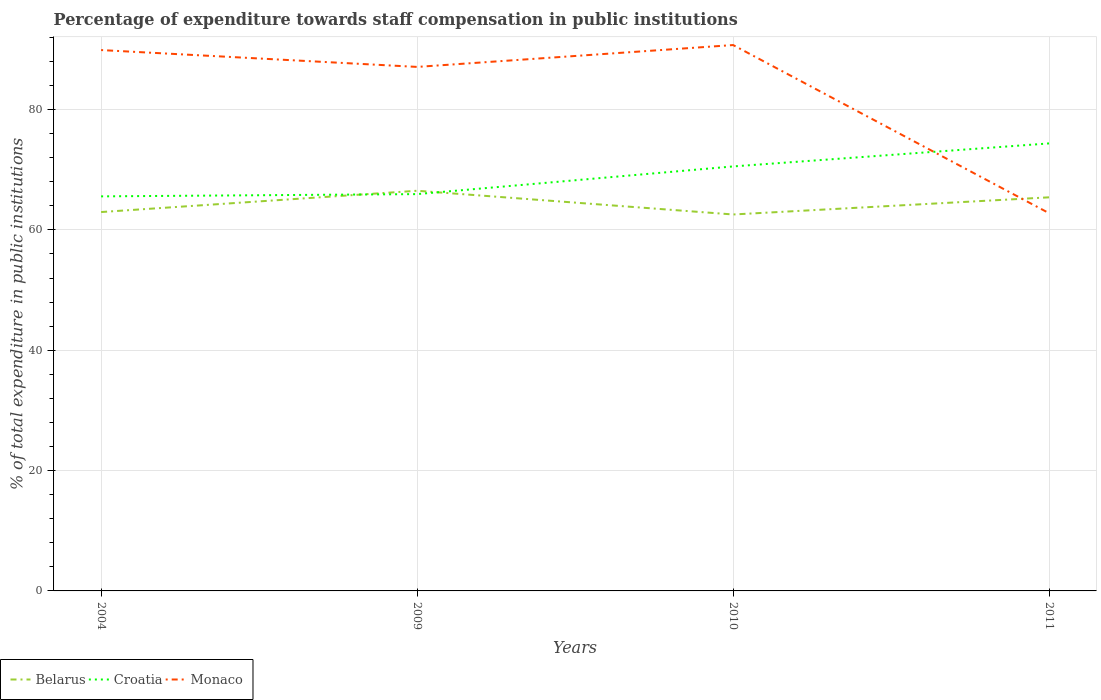Does the line corresponding to Monaco intersect with the line corresponding to Belarus?
Your answer should be compact. Yes. Across all years, what is the maximum percentage of expenditure towards staff compensation in Belarus?
Offer a very short reply. 62.57. What is the total percentage of expenditure towards staff compensation in Belarus in the graph?
Keep it short and to the point. -3.54. What is the difference between the highest and the second highest percentage of expenditure towards staff compensation in Belarus?
Provide a short and direct response. 3.94. What is the difference between the highest and the lowest percentage of expenditure towards staff compensation in Monaco?
Provide a short and direct response. 3. Is the percentage of expenditure towards staff compensation in Belarus strictly greater than the percentage of expenditure towards staff compensation in Monaco over the years?
Give a very brief answer. No. How many years are there in the graph?
Offer a terse response. 4. What is the difference between two consecutive major ticks on the Y-axis?
Offer a very short reply. 20. Are the values on the major ticks of Y-axis written in scientific E-notation?
Keep it short and to the point. No. Does the graph contain any zero values?
Keep it short and to the point. No. Where does the legend appear in the graph?
Provide a succinct answer. Bottom left. How many legend labels are there?
Keep it short and to the point. 3. What is the title of the graph?
Provide a succinct answer. Percentage of expenditure towards staff compensation in public institutions. Does "Andorra" appear as one of the legend labels in the graph?
Keep it short and to the point. No. What is the label or title of the X-axis?
Provide a succinct answer. Years. What is the label or title of the Y-axis?
Provide a succinct answer. % of total expenditure in public institutions. What is the % of total expenditure in public institutions in Belarus in 2004?
Make the answer very short. 62.97. What is the % of total expenditure in public institutions in Croatia in 2004?
Provide a short and direct response. 65.58. What is the % of total expenditure in public institutions in Monaco in 2004?
Your answer should be compact. 89.9. What is the % of total expenditure in public institutions of Belarus in 2009?
Ensure brevity in your answer.  66.51. What is the % of total expenditure in public institutions in Croatia in 2009?
Your answer should be very brief. 65.95. What is the % of total expenditure in public institutions in Monaco in 2009?
Your answer should be compact. 87.1. What is the % of total expenditure in public institutions of Belarus in 2010?
Your answer should be compact. 62.57. What is the % of total expenditure in public institutions in Croatia in 2010?
Offer a very short reply. 70.56. What is the % of total expenditure in public institutions of Monaco in 2010?
Keep it short and to the point. 90.73. What is the % of total expenditure in public institutions in Belarus in 2011?
Give a very brief answer. 65.42. What is the % of total expenditure in public institutions in Croatia in 2011?
Your answer should be very brief. 74.38. What is the % of total expenditure in public institutions of Monaco in 2011?
Your response must be concise. 62.78. Across all years, what is the maximum % of total expenditure in public institutions in Belarus?
Make the answer very short. 66.51. Across all years, what is the maximum % of total expenditure in public institutions in Croatia?
Ensure brevity in your answer.  74.38. Across all years, what is the maximum % of total expenditure in public institutions in Monaco?
Your answer should be very brief. 90.73. Across all years, what is the minimum % of total expenditure in public institutions of Belarus?
Provide a succinct answer. 62.57. Across all years, what is the minimum % of total expenditure in public institutions in Croatia?
Your answer should be compact. 65.58. Across all years, what is the minimum % of total expenditure in public institutions of Monaco?
Give a very brief answer. 62.78. What is the total % of total expenditure in public institutions of Belarus in the graph?
Make the answer very short. 257.47. What is the total % of total expenditure in public institutions in Croatia in the graph?
Keep it short and to the point. 276.47. What is the total % of total expenditure in public institutions in Monaco in the graph?
Make the answer very short. 330.5. What is the difference between the % of total expenditure in public institutions of Belarus in 2004 and that in 2009?
Keep it short and to the point. -3.54. What is the difference between the % of total expenditure in public institutions of Croatia in 2004 and that in 2009?
Your response must be concise. -0.38. What is the difference between the % of total expenditure in public institutions in Monaco in 2004 and that in 2009?
Provide a short and direct response. 2.8. What is the difference between the % of total expenditure in public institutions in Belarus in 2004 and that in 2010?
Provide a short and direct response. 0.41. What is the difference between the % of total expenditure in public institutions in Croatia in 2004 and that in 2010?
Make the answer very short. -4.98. What is the difference between the % of total expenditure in public institutions in Monaco in 2004 and that in 2010?
Make the answer very short. -0.83. What is the difference between the % of total expenditure in public institutions of Belarus in 2004 and that in 2011?
Keep it short and to the point. -2.45. What is the difference between the % of total expenditure in public institutions of Croatia in 2004 and that in 2011?
Make the answer very short. -8.8. What is the difference between the % of total expenditure in public institutions of Monaco in 2004 and that in 2011?
Offer a very short reply. 27.11. What is the difference between the % of total expenditure in public institutions in Belarus in 2009 and that in 2010?
Provide a short and direct response. 3.94. What is the difference between the % of total expenditure in public institutions in Croatia in 2009 and that in 2010?
Make the answer very short. -4.6. What is the difference between the % of total expenditure in public institutions in Monaco in 2009 and that in 2010?
Your answer should be compact. -3.63. What is the difference between the % of total expenditure in public institutions of Belarus in 2009 and that in 2011?
Provide a succinct answer. 1.09. What is the difference between the % of total expenditure in public institutions in Croatia in 2009 and that in 2011?
Your answer should be compact. -8.43. What is the difference between the % of total expenditure in public institutions of Monaco in 2009 and that in 2011?
Give a very brief answer. 24.31. What is the difference between the % of total expenditure in public institutions of Belarus in 2010 and that in 2011?
Give a very brief answer. -2.85. What is the difference between the % of total expenditure in public institutions of Croatia in 2010 and that in 2011?
Your response must be concise. -3.82. What is the difference between the % of total expenditure in public institutions of Monaco in 2010 and that in 2011?
Offer a terse response. 27.95. What is the difference between the % of total expenditure in public institutions of Belarus in 2004 and the % of total expenditure in public institutions of Croatia in 2009?
Provide a short and direct response. -2.98. What is the difference between the % of total expenditure in public institutions of Belarus in 2004 and the % of total expenditure in public institutions of Monaco in 2009?
Your answer should be very brief. -24.12. What is the difference between the % of total expenditure in public institutions of Croatia in 2004 and the % of total expenditure in public institutions of Monaco in 2009?
Offer a terse response. -21.52. What is the difference between the % of total expenditure in public institutions of Belarus in 2004 and the % of total expenditure in public institutions of Croatia in 2010?
Provide a short and direct response. -7.58. What is the difference between the % of total expenditure in public institutions of Belarus in 2004 and the % of total expenditure in public institutions of Monaco in 2010?
Ensure brevity in your answer.  -27.76. What is the difference between the % of total expenditure in public institutions in Croatia in 2004 and the % of total expenditure in public institutions in Monaco in 2010?
Offer a very short reply. -25.15. What is the difference between the % of total expenditure in public institutions of Belarus in 2004 and the % of total expenditure in public institutions of Croatia in 2011?
Provide a succinct answer. -11.41. What is the difference between the % of total expenditure in public institutions in Belarus in 2004 and the % of total expenditure in public institutions in Monaco in 2011?
Make the answer very short. 0.19. What is the difference between the % of total expenditure in public institutions of Croatia in 2004 and the % of total expenditure in public institutions of Monaco in 2011?
Provide a short and direct response. 2.8. What is the difference between the % of total expenditure in public institutions in Belarus in 2009 and the % of total expenditure in public institutions in Croatia in 2010?
Make the answer very short. -4.04. What is the difference between the % of total expenditure in public institutions in Belarus in 2009 and the % of total expenditure in public institutions in Monaco in 2010?
Keep it short and to the point. -24.22. What is the difference between the % of total expenditure in public institutions of Croatia in 2009 and the % of total expenditure in public institutions of Monaco in 2010?
Give a very brief answer. -24.78. What is the difference between the % of total expenditure in public institutions of Belarus in 2009 and the % of total expenditure in public institutions of Croatia in 2011?
Provide a succinct answer. -7.87. What is the difference between the % of total expenditure in public institutions in Belarus in 2009 and the % of total expenditure in public institutions in Monaco in 2011?
Your answer should be compact. 3.73. What is the difference between the % of total expenditure in public institutions in Croatia in 2009 and the % of total expenditure in public institutions in Monaco in 2011?
Make the answer very short. 3.17. What is the difference between the % of total expenditure in public institutions of Belarus in 2010 and the % of total expenditure in public institutions of Croatia in 2011?
Provide a succinct answer. -11.81. What is the difference between the % of total expenditure in public institutions in Belarus in 2010 and the % of total expenditure in public institutions in Monaco in 2011?
Provide a short and direct response. -0.21. What is the difference between the % of total expenditure in public institutions in Croatia in 2010 and the % of total expenditure in public institutions in Monaco in 2011?
Provide a short and direct response. 7.77. What is the average % of total expenditure in public institutions in Belarus per year?
Ensure brevity in your answer.  64.37. What is the average % of total expenditure in public institutions of Croatia per year?
Give a very brief answer. 69.12. What is the average % of total expenditure in public institutions of Monaco per year?
Provide a short and direct response. 82.63. In the year 2004, what is the difference between the % of total expenditure in public institutions of Belarus and % of total expenditure in public institutions of Croatia?
Give a very brief answer. -2.61. In the year 2004, what is the difference between the % of total expenditure in public institutions in Belarus and % of total expenditure in public institutions in Monaco?
Offer a terse response. -26.92. In the year 2004, what is the difference between the % of total expenditure in public institutions of Croatia and % of total expenditure in public institutions of Monaco?
Make the answer very short. -24.32. In the year 2009, what is the difference between the % of total expenditure in public institutions in Belarus and % of total expenditure in public institutions in Croatia?
Offer a terse response. 0.56. In the year 2009, what is the difference between the % of total expenditure in public institutions of Belarus and % of total expenditure in public institutions of Monaco?
Offer a terse response. -20.58. In the year 2009, what is the difference between the % of total expenditure in public institutions in Croatia and % of total expenditure in public institutions in Monaco?
Ensure brevity in your answer.  -21.14. In the year 2010, what is the difference between the % of total expenditure in public institutions of Belarus and % of total expenditure in public institutions of Croatia?
Offer a terse response. -7.99. In the year 2010, what is the difference between the % of total expenditure in public institutions in Belarus and % of total expenditure in public institutions in Monaco?
Your answer should be very brief. -28.16. In the year 2010, what is the difference between the % of total expenditure in public institutions in Croatia and % of total expenditure in public institutions in Monaco?
Ensure brevity in your answer.  -20.17. In the year 2011, what is the difference between the % of total expenditure in public institutions of Belarus and % of total expenditure in public institutions of Croatia?
Your answer should be very brief. -8.96. In the year 2011, what is the difference between the % of total expenditure in public institutions in Belarus and % of total expenditure in public institutions in Monaco?
Keep it short and to the point. 2.64. In the year 2011, what is the difference between the % of total expenditure in public institutions of Croatia and % of total expenditure in public institutions of Monaco?
Provide a short and direct response. 11.6. What is the ratio of the % of total expenditure in public institutions of Belarus in 2004 to that in 2009?
Give a very brief answer. 0.95. What is the ratio of the % of total expenditure in public institutions of Croatia in 2004 to that in 2009?
Your answer should be compact. 0.99. What is the ratio of the % of total expenditure in public institutions in Monaco in 2004 to that in 2009?
Provide a succinct answer. 1.03. What is the ratio of the % of total expenditure in public institutions of Belarus in 2004 to that in 2010?
Your answer should be compact. 1.01. What is the ratio of the % of total expenditure in public institutions in Croatia in 2004 to that in 2010?
Keep it short and to the point. 0.93. What is the ratio of the % of total expenditure in public institutions in Monaco in 2004 to that in 2010?
Your answer should be very brief. 0.99. What is the ratio of the % of total expenditure in public institutions in Belarus in 2004 to that in 2011?
Offer a terse response. 0.96. What is the ratio of the % of total expenditure in public institutions in Croatia in 2004 to that in 2011?
Your answer should be compact. 0.88. What is the ratio of the % of total expenditure in public institutions of Monaco in 2004 to that in 2011?
Offer a terse response. 1.43. What is the ratio of the % of total expenditure in public institutions in Belarus in 2009 to that in 2010?
Keep it short and to the point. 1.06. What is the ratio of the % of total expenditure in public institutions in Croatia in 2009 to that in 2010?
Keep it short and to the point. 0.93. What is the ratio of the % of total expenditure in public institutions of Monaco in 2009 to that in 2010?
Provide a succinct answer. 0.96. What is the ratio of the % of total expenditure in public institutions in Belarus in 2009 to that in 2011?
Keep it short and to the point. 1.02. What is the ratio of the % of total expenditure in public institutions in Croatia in 2009 to that in 2011?
Make the answer very short. 0.89. What is the ratio of the % of total expenditure in public institutions of Monaco in 2009 to that in 2011?
Ensure brevity in your answer.  1.39. What is the ratio of the % of total expenditure in public institutions of Belarus in 2010 to that in 2011?
Your response must be concise. 0.96. What is the ratio of the % of total expenditure in public institutions of Croatia in 2010 to that in 2011?
Give a very brief answer. 0.95. What is the ratio of the % of total expenditure in public institutions of Monaco in 2010 to that in 2011?
Provide a succinct answer. 1.45. What is the difference between the highest and the second highest % of total expenditure in public institutions in Belarus?
Offer a very short reply. 1.09. What is the difference between the highest and the second highest % of total expenditure in public institutions of Croatia?
Make the answer very short. 3.82. What is the difference between the highest and the second highest % of total expenditure in public institutions of Monaco?
Your answer should be compact. 0.83. What is the difference between the highest and the lowest % of total expenditure in public institutions in Belarus?
Offer a terse response. 3.94. What is the difference between the highest and the lowest % of total expenditure in public institutions in Croatia?
Your response must be concise. 8.8. What is the difference between the highest and the lowest % of total expenditure in public institutions in Monaco?
Provide a succinct answer. 27.95. 